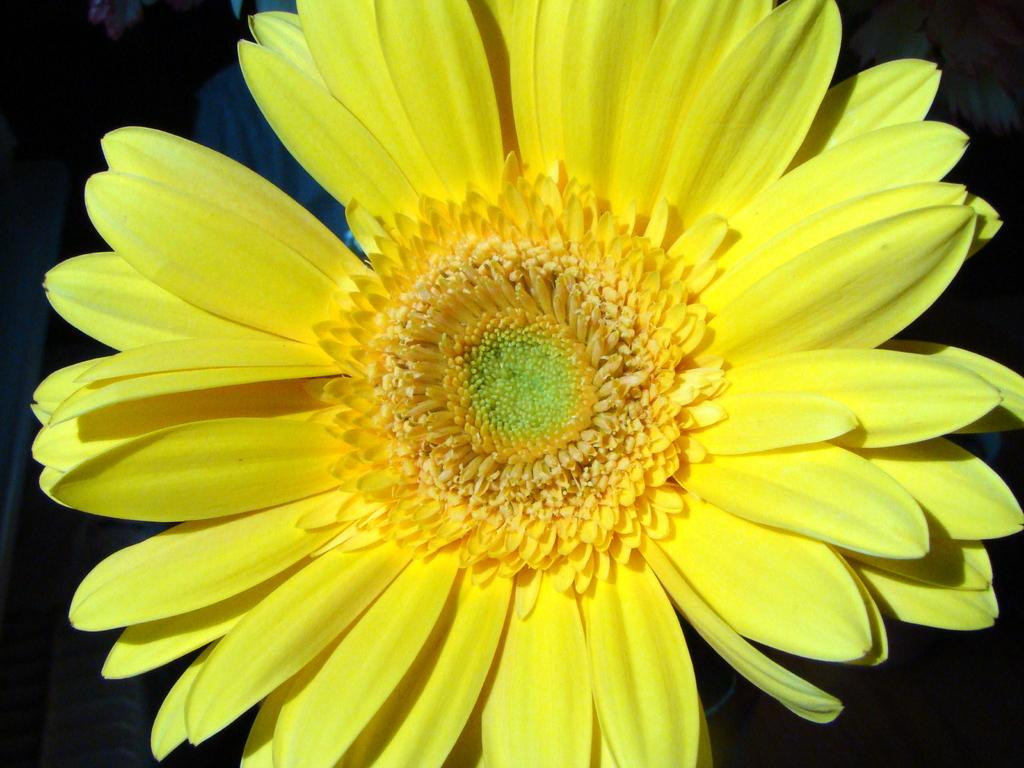What is the main subject of the image? There is a flower in the image. Are there any dinosaurs visible in the image? No, there are no dinosaurs present in the image; it features a flower. What type of coil can be seen in the image? There is no coil present in the image; it features a flower. 